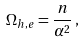Convert formula to latex. <formula><loc_0><loc_0><loc_500><loc_500>\Omega _ { h , e } = \frac { n } { \alpha ^ { 2 } } \, ,</formula> 